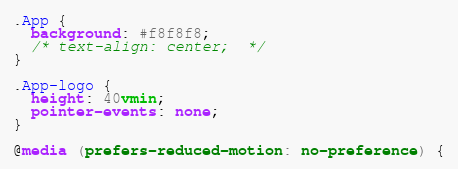<code> <loc_0><loc_0><loc_500><loc_500><_CSS_>.App {
  background: #f8f8f8;
  /* text-align: center;  */
}

.App-logo {
  height: 40vmin;
  pointer-events: none;
}

@media (prefers-reduced-motion: no-preference) {</code> 